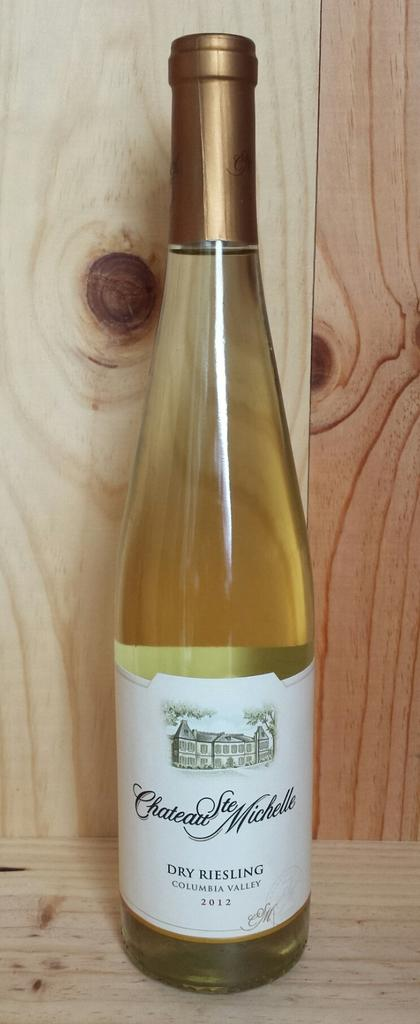<image>
Give a short and clear explanation of the subsequent image. Bottle of alcohol with a label that says "Dry Riesling" on it. 